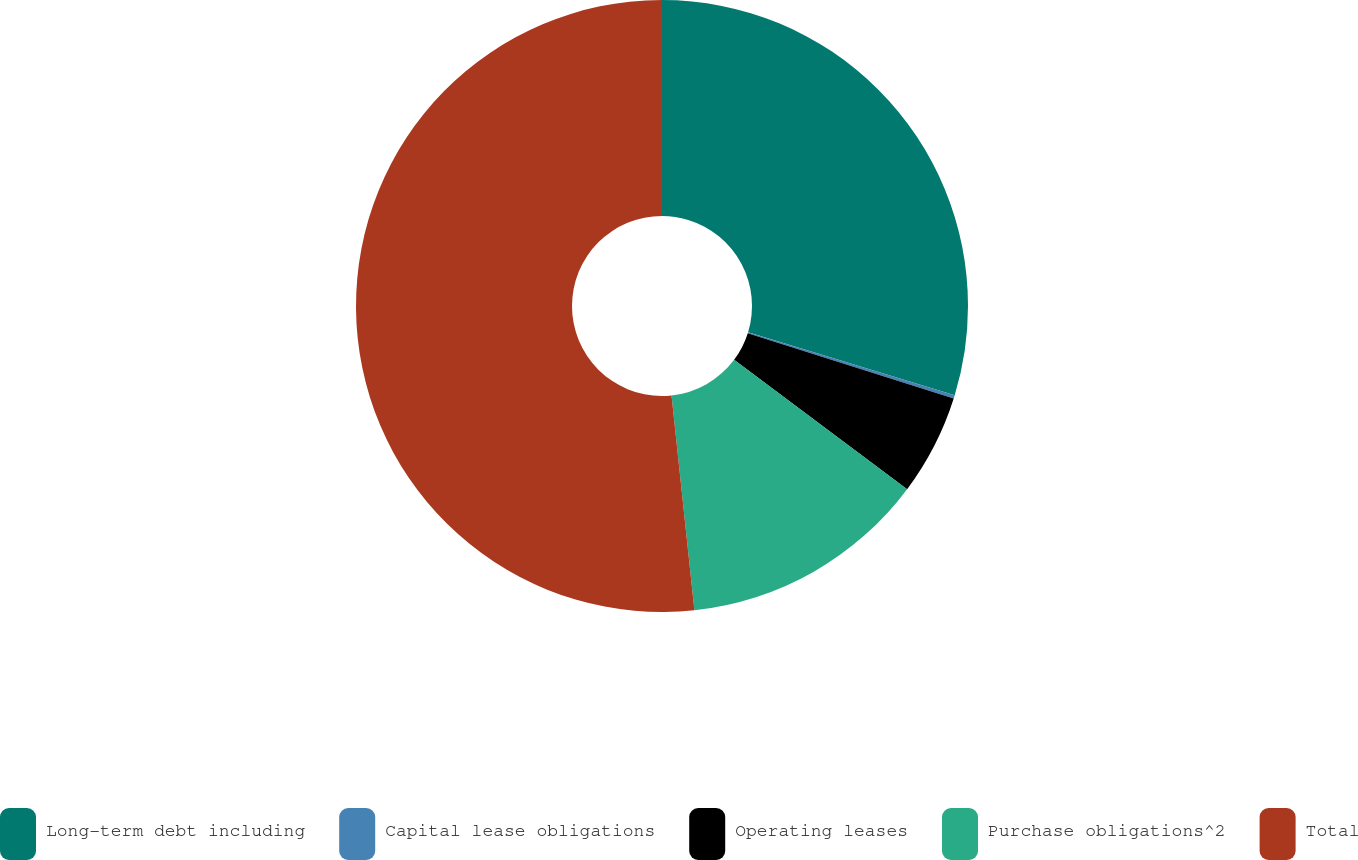Convert chart to OTSL. <chart><loc_0><loc_0><loc_500><loc_500><pie_chart><fcel>Long-term debt including<fcel>Capital lease obligations<fcel>Operating leases<fcel>Purchase obligations^2<fcel>Total<nl><fcel>29.71%<fcel>0.18%<fcel>5.33%<fcel>13.1%<fcel>51.7%<nl></chart> 